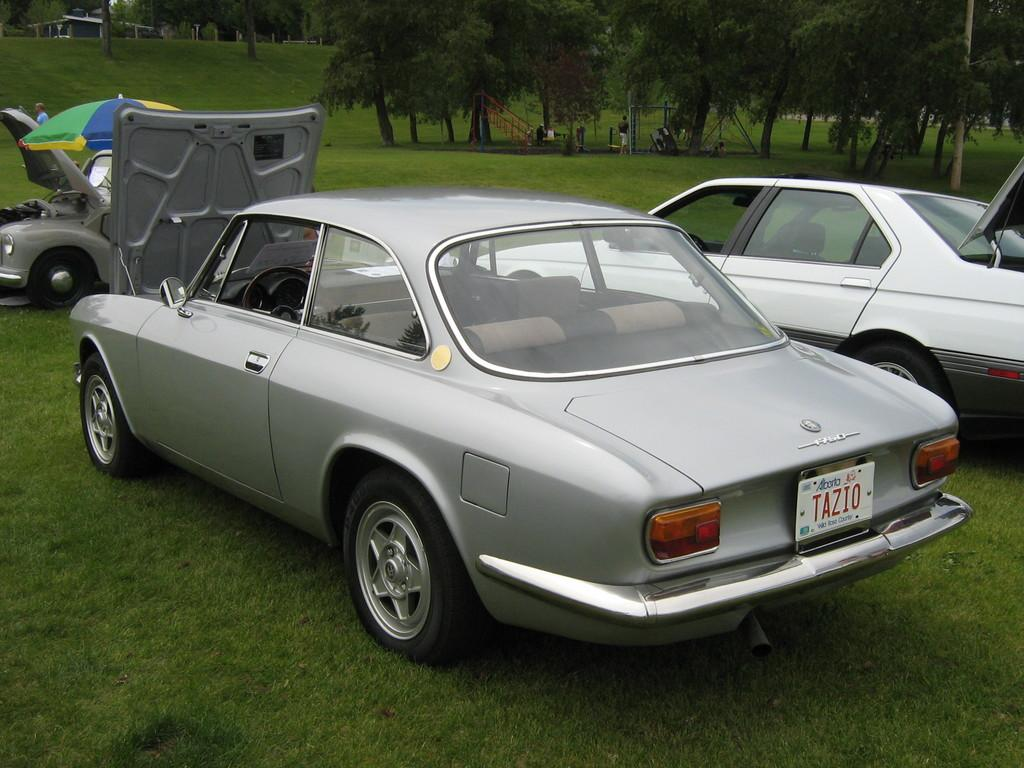How many cars are in the image? There are three cars in the image. What can be observed about the colors of the cars? The cars are in different colors. What else can be seen in the background of the image? There are people and trees visible in the background. What additional object can be seen in the image? There is a colorful umbrella in the image. What type of structure is visible in the background? There is a shed visible in the background. What type of button is being used to control the flight of the car in the image? There is no button or flight control depicted in the image; it features three cars and various background elements. What type of boot is visible on the person in the image? There are no people close enough to see their footwear in the image. 